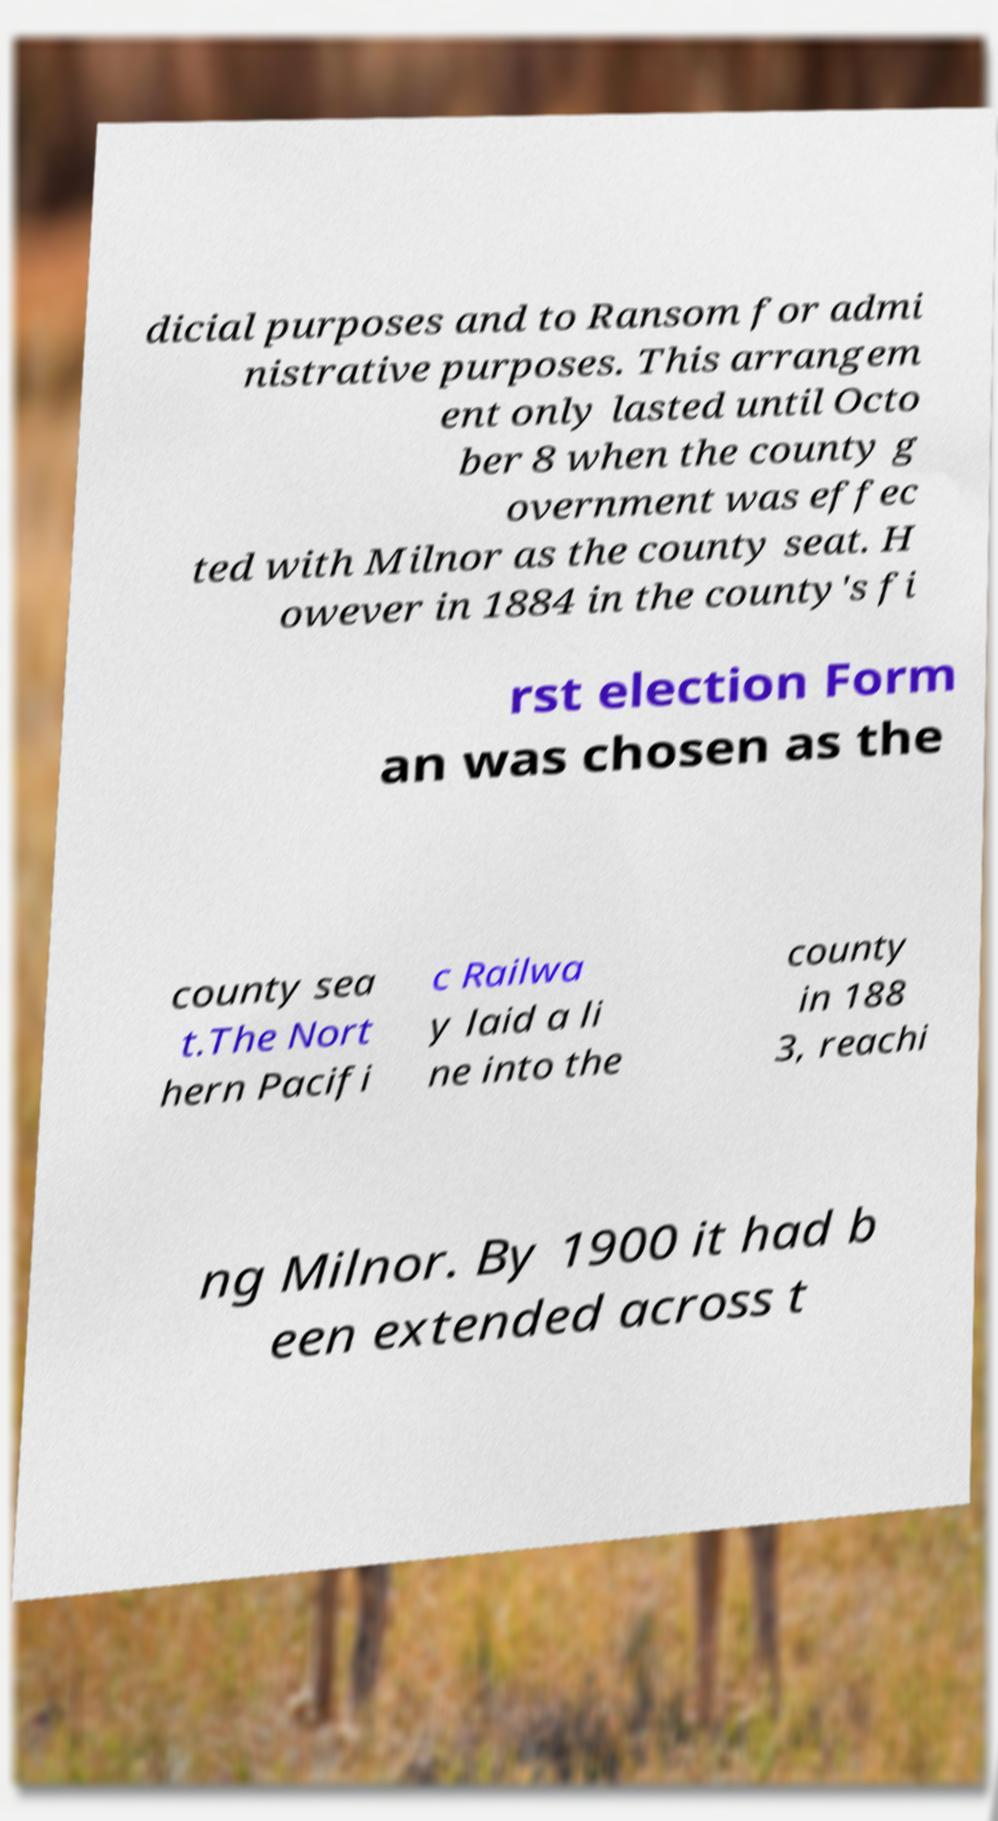Please read and relay the text visible in this image. What does it say? dicial purposes and to Ransom for admi nistrative purposes. This arrangem ent only lasted until Octo ber 8 when the county g overnment was effec ted with Milnor as the county seat. H owever in 1884 in the county's fi rst election Form an was chosen as the county sea t.The Nort hern Pacifi c Railwa y laid a li ne into the county in 188 3, reachi ng Milnor. By 1900 it had b een extended across t 